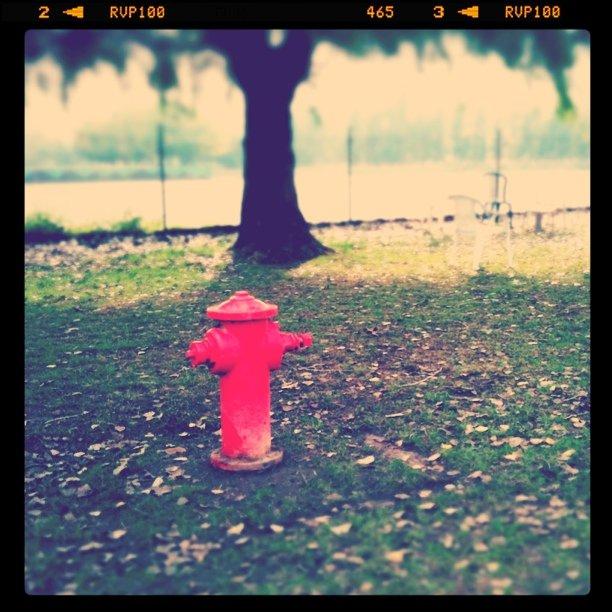What is next to the hydrant?
Quick response, please. Tree. The tree behind the fire hydrant has what kind of effect over it?
Keep it brief. Blur. Is the fire hydrant in use?
Keep it brief. No. What has been done to the white balance in this photo?
Quick response, please. Altered. What color is the fire hydrant?
Concise answer only. Red. 